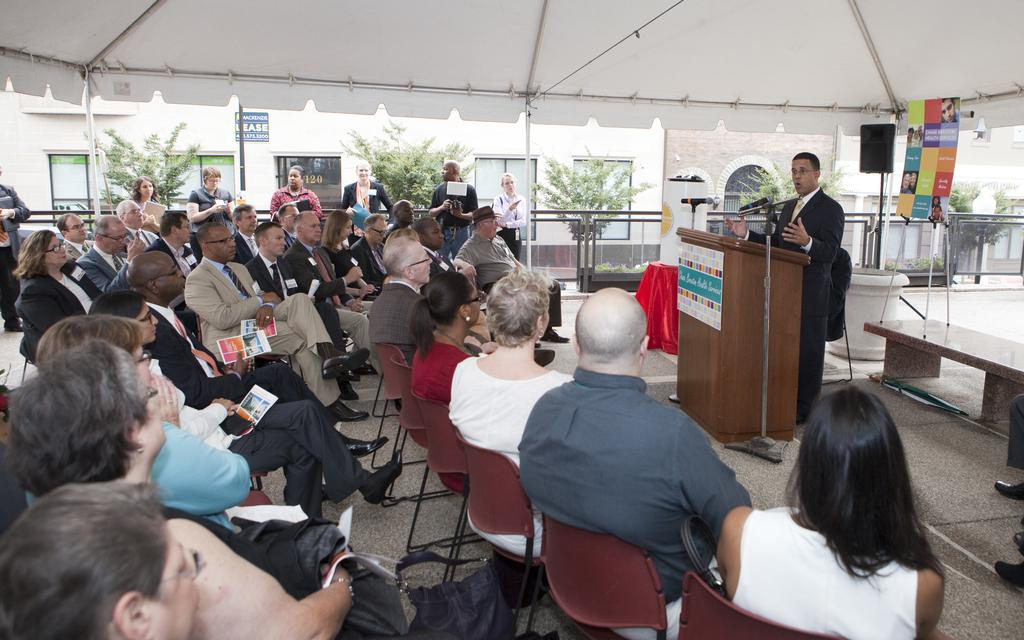What are the people in the image doing? There are people sitting in chairs and people standing in front of a podium. What are the people standing in front of the podium doing? They are talking into a microphone. What can be seen near the people in the image? There are plants near the people. What is visible in the background of the image? There is a building visible in the image. What type of metal is being used to create pain in the image? There is no mention of metal or pain in the image; it features people sitting and standing near a podium. Is there any indication of war in the image? No, there is no indication of war in the image; it shows people in a setting that could be a conference or presentation. 